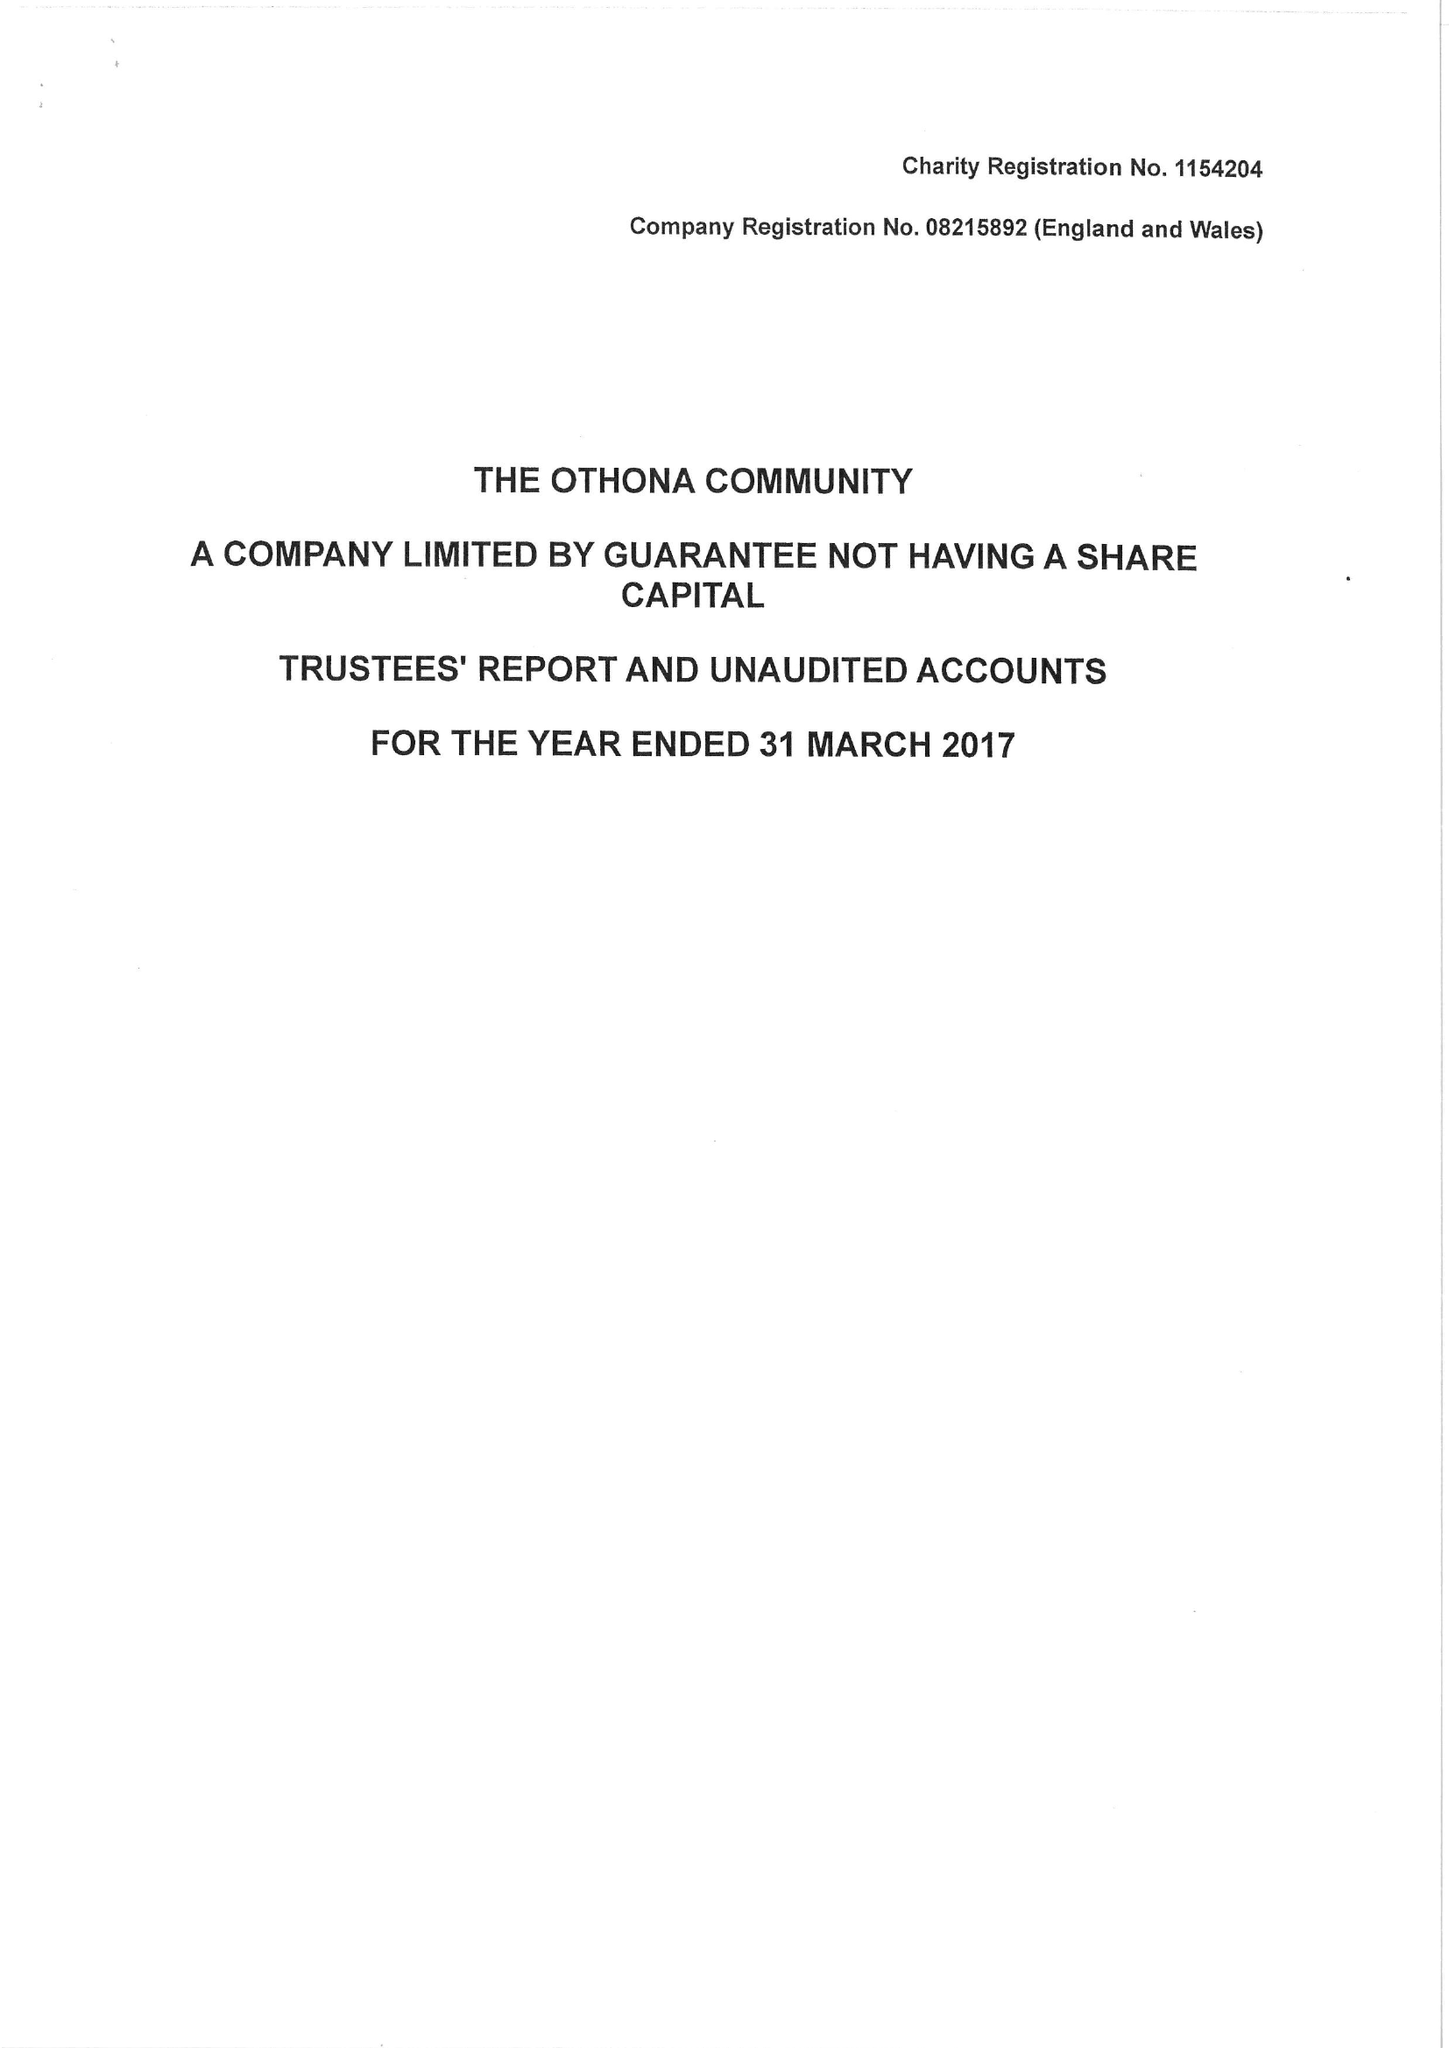What is the value for the charity_number?
Answer the question using a single word or phrase. 1154204 